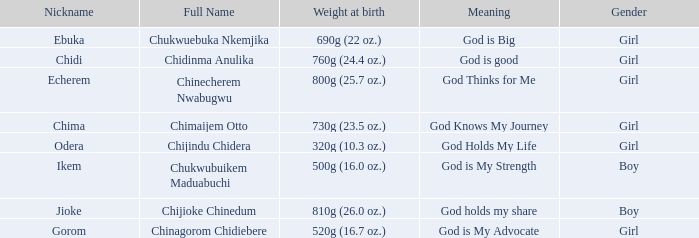What is the nickname of the baby with the birth weight of 730g (23.5 oz.)? Chima. 